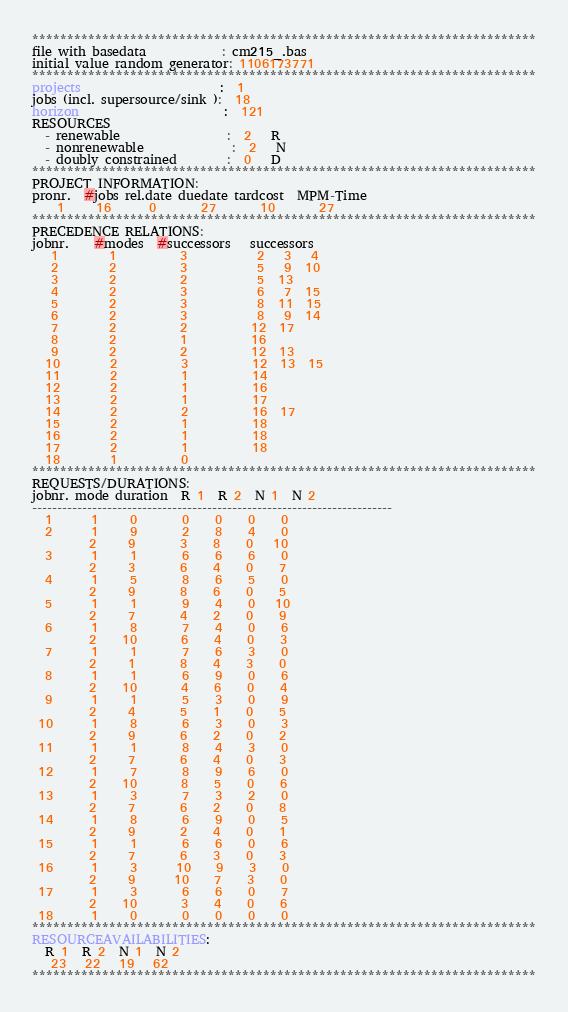Convert code to text. <code><loc_0><loc_0><loc_500><loc_500><_ObjectiveC_>************************************************************************
file with basedata            : cm215_.bas
initial value random generator: 1106173771
************************************************************************
projects                      :  1
jobs (incl. supersource/sink ):  18
horizon                       :  121
RESOURCES
  - renewable                 :  2   R
  - nonrenewable              :  2   N
  - doubly constrained        :  0   D
************************************************************************
PROJECT INFORMATION:
pronr.  #jobs rel.date duedate tardcost  MPM-Time
    1     16      0       27       10       27
************************************************************************
PRECEDENCE RELATIONS:
jobnr.    #modes  #successors   successors
   1        1          3           2   3   4
   2        2          3           5   9  10
   3        2          2           5  13
   4        2          3           6   7  15
   5        2          3           8  11  15
   6        2          3           8   9  14
   7        2          2          12  17
   8        2          1          16
   9        2          2          12  13
  10        2          3          12  13  15
  11        2          1          14
  12        2          1          16
  13        2          1          17
  14        2          2          16  17
  15        2          1          18
  16        2          1          18
  17        2          1          18
  18        1          0        
************************************************************************
REQUESTS/DURATIONS:
jobnr. mode duration  R 1  R 2  N 1  N 2
------------------------------------------------------------------------
  1      1     0       0    0    0    0
  2      1     9       2    8    4    0
         2     9       3    8    0   10
  3      1     1       6    6    6    0
         2     3       6    4    0    7
  4      1     5       8    6    5    0
         2     9       8    6    0    5
  5      1     1       9    4    0   10
         2     7       4    2    0    9
  6      1     8       7    4    0    6
         2    10       6    4    0    3
  7      1     1       7    6    3    0
         2     1       8    4    3    0
  8      1     1       6    9    0    6
         2    10       4    6    0    4
  9      1     1       5    3    0    9
         2     4       5    1    0    5
 10      1     8       6    3    0    3
         2     9       6    2    0    2
 11      1     1       8    4    3    0
         2     7       6    4    0    3
 12      1     7       8    9    6    0
         2    10       8    5    0    6
 13      1     3       7    3    2    0
         2     7       6    2    0    8
 14      1     8       6    9    0    5
         2     9       2    4    0    1
 15      1     1       6    6    0    6
         2     7       6    3    0    3
 16      1     3      10    9    3    0
         2     9      10    7    3    0
 17      1     3       6    6    0    7
         2    10       3    4    0    6
 18      1     0       0    0    0    0
************************************************************************
RESOURCEAVAILABILITIES:
  R 1  R 2  N 1  N 2
   23   22   19   62
************************************************************************
</code> 